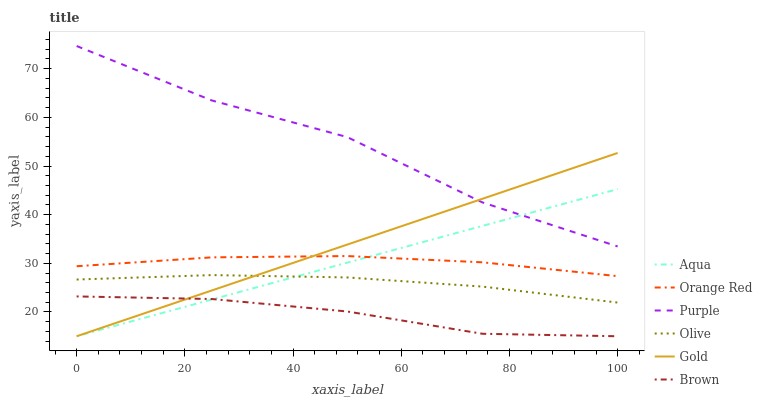Does Gold have the minimum area under the curve?
Answer yes or no. No. Does Gold have the maximum area under the curve?
Answer yes or no. No. Is Purple the smoothest?
Answer yes or no. No. Is Gold the roughest?
Answer yes or no. No. Does Purple have the lowest value?
Answer yes or no. No. Does Gold have the highest value?
Answer yes or no. No. Is Orange Red less than Purple?
Answer yes or no. Yes. Is Purple greater than Orange Red?
Answer yes or no. Yes. Does Orange Red intersect Purple?
Answer yes or no. No. 